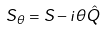<formula> <loc_0><loc_0><loc_500><loc_500>S _ { \theta } = S - i \theta \hat { Q }</formula> 